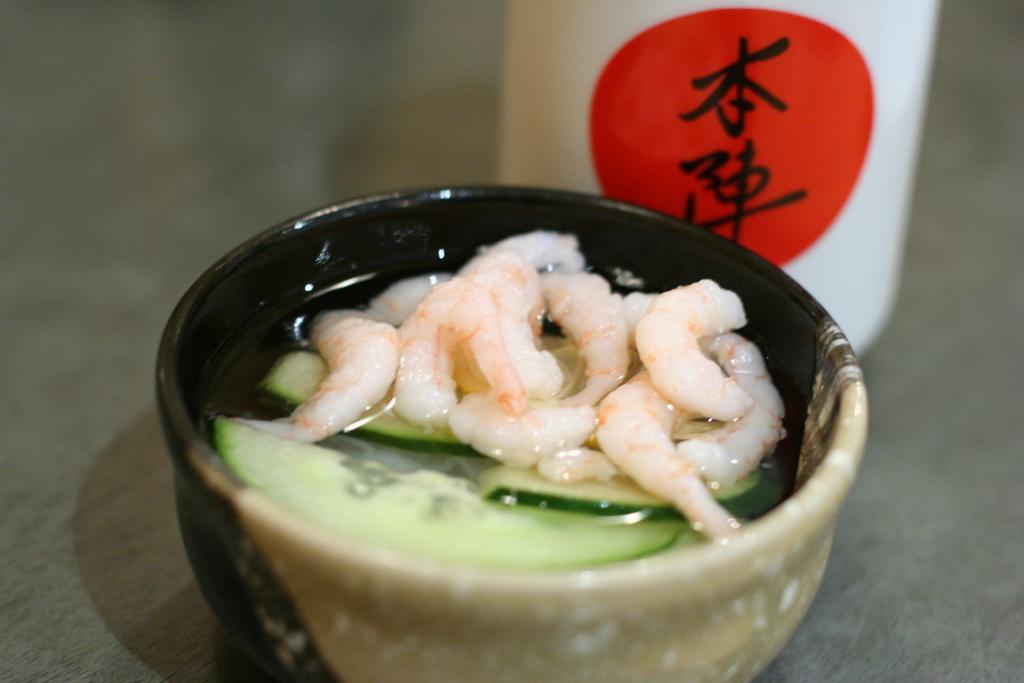Can you describe this image briefly? In this picture we can see food in the bowl, behind to the bowl we can find an object. 